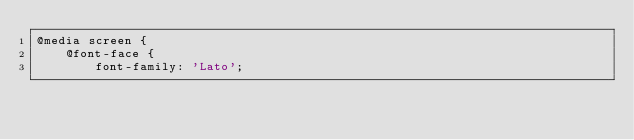<code> <loc_0><loc_0><loc_500><loc_500><_CSS_>@media screen {
    @font-face {
        font-family: 'Lato';</code> 